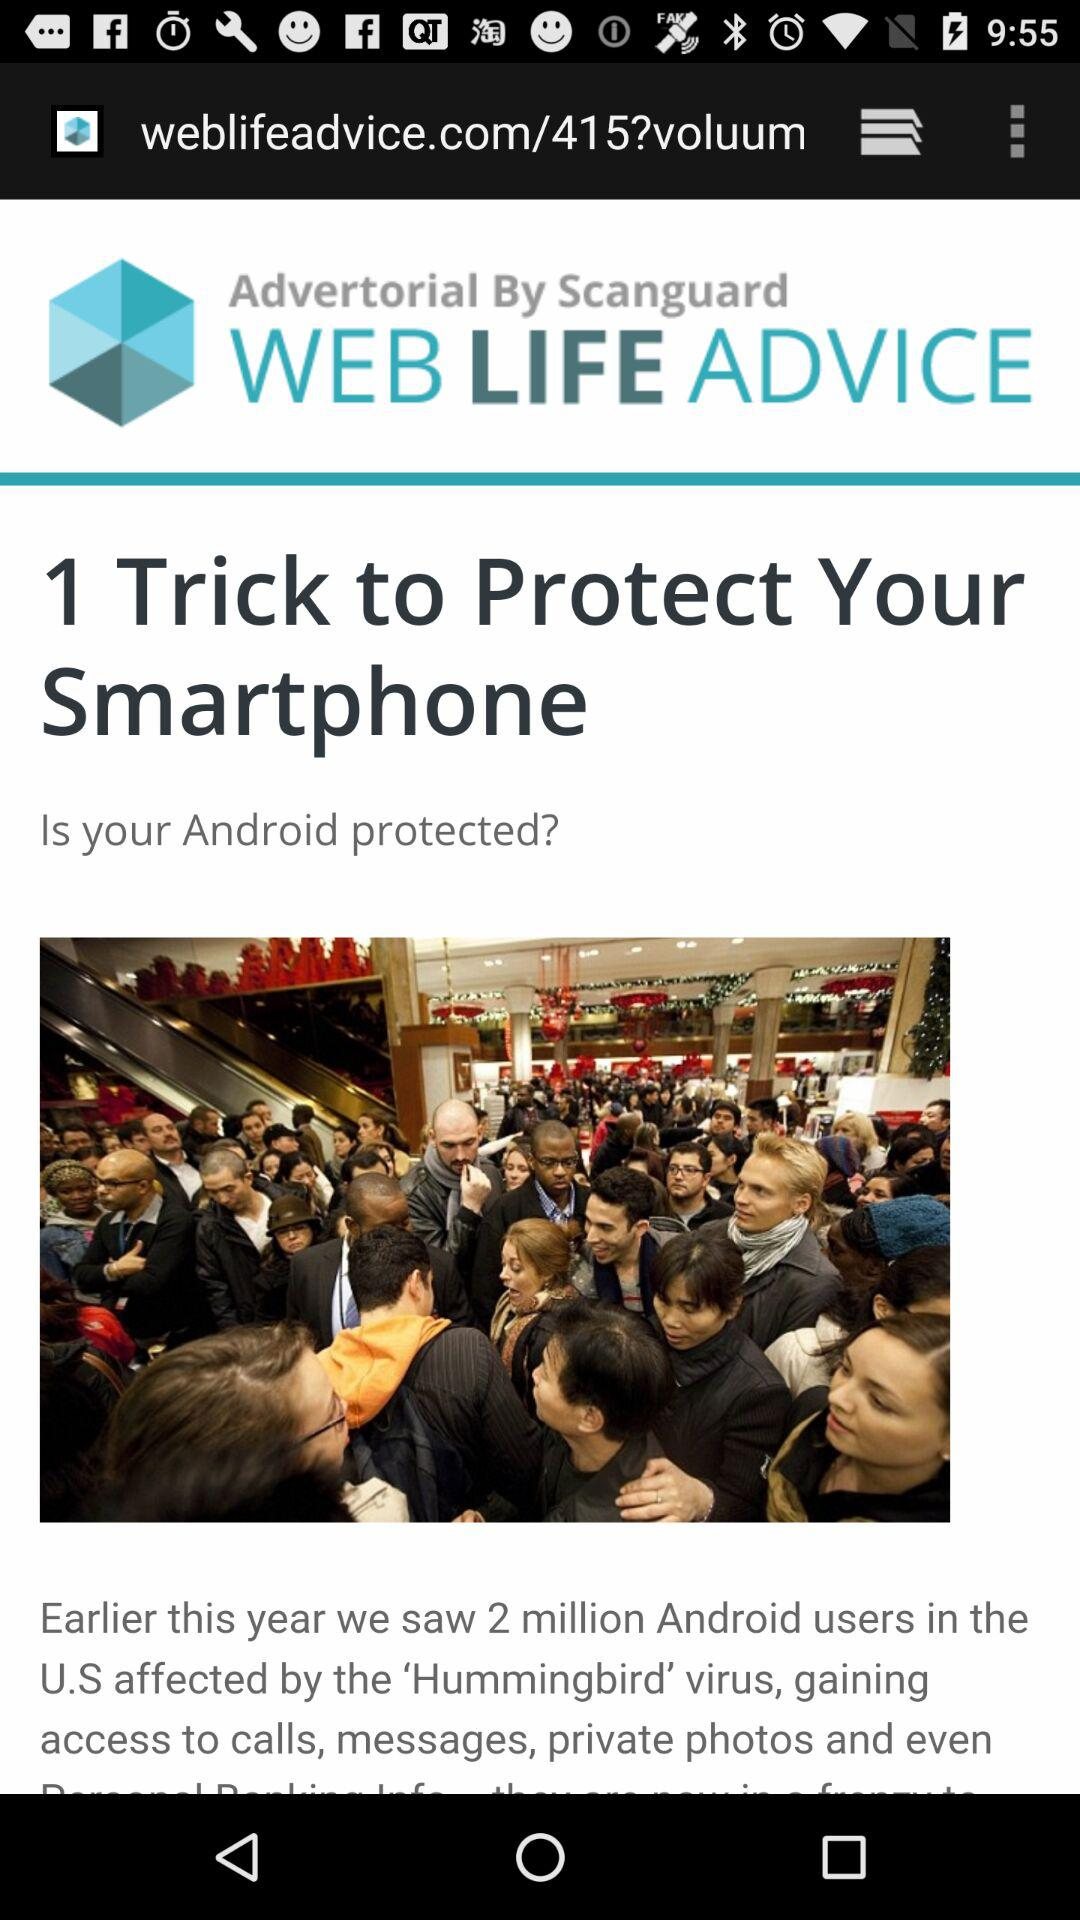How many Android users were affected by the 'Hummingbird' virus in the U.S.? There were 2 million Android users that were affected by the 'Hummingbird' virus. 